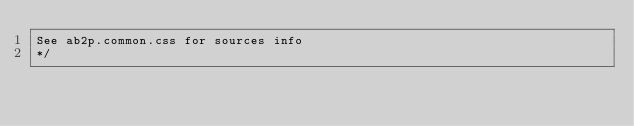<code> <loc_0><loc_0><loc_500><loc_500><_CSS_>See ab2p.common.css for sources info
*/</code> 